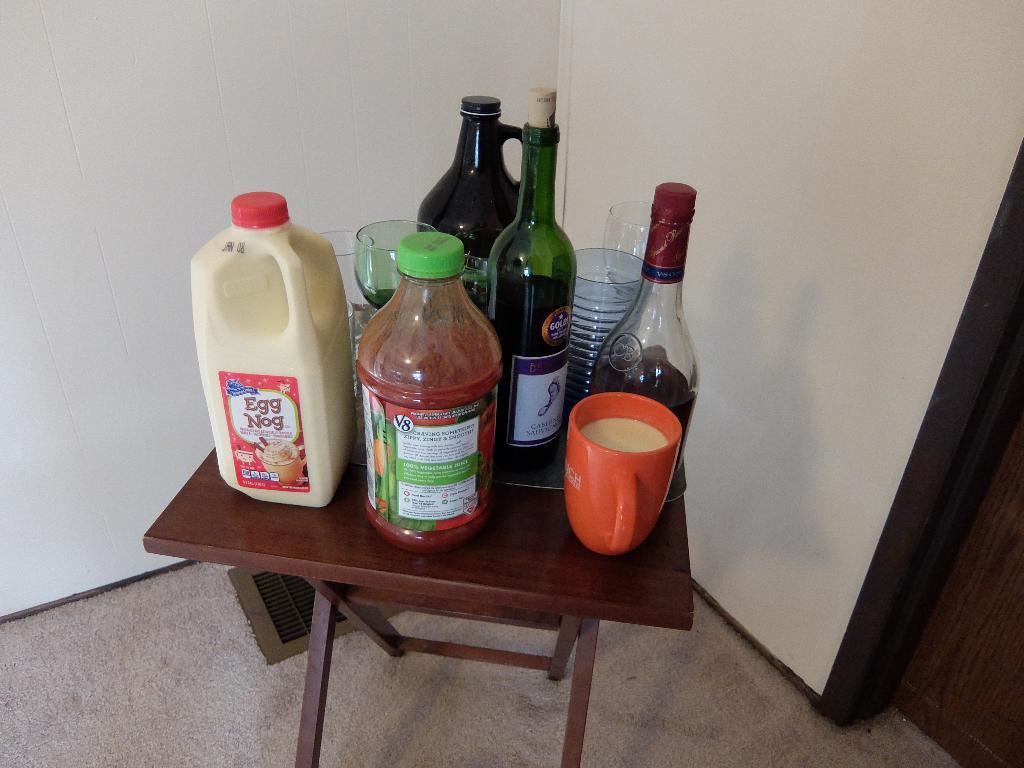What brand of drink is in the closest bottle?
Make the answer very short. V8. 